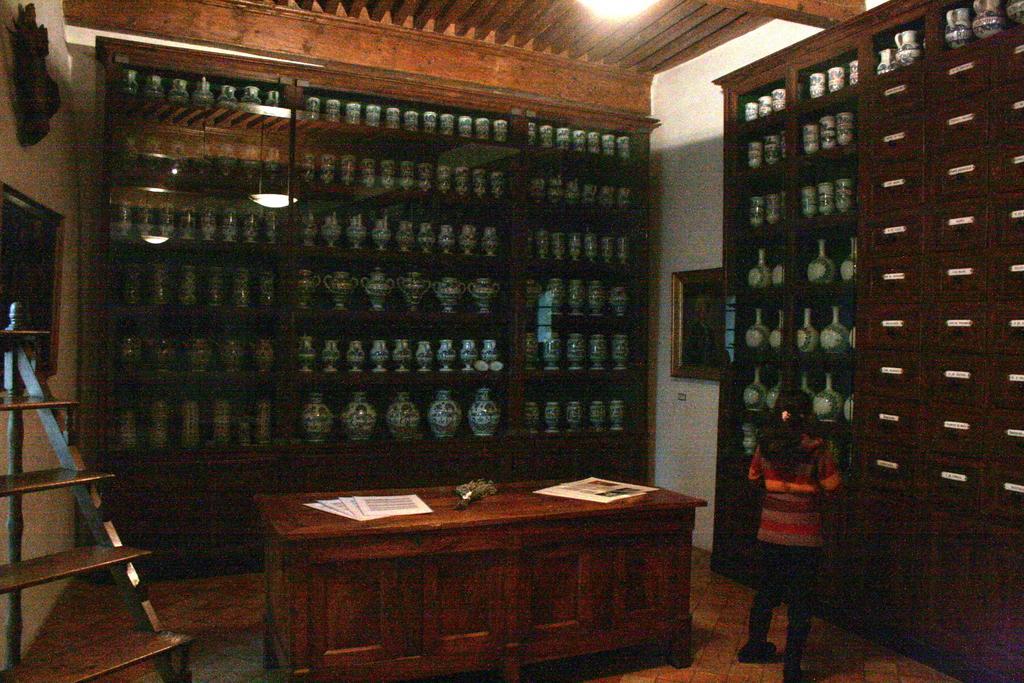Describe this image in one or two sentences. In this image I see many faces in the racks and I see a girl over here and on this table I see few papers and there is a ladder over here and I can also see a photo frame on this wall and a light over here. 